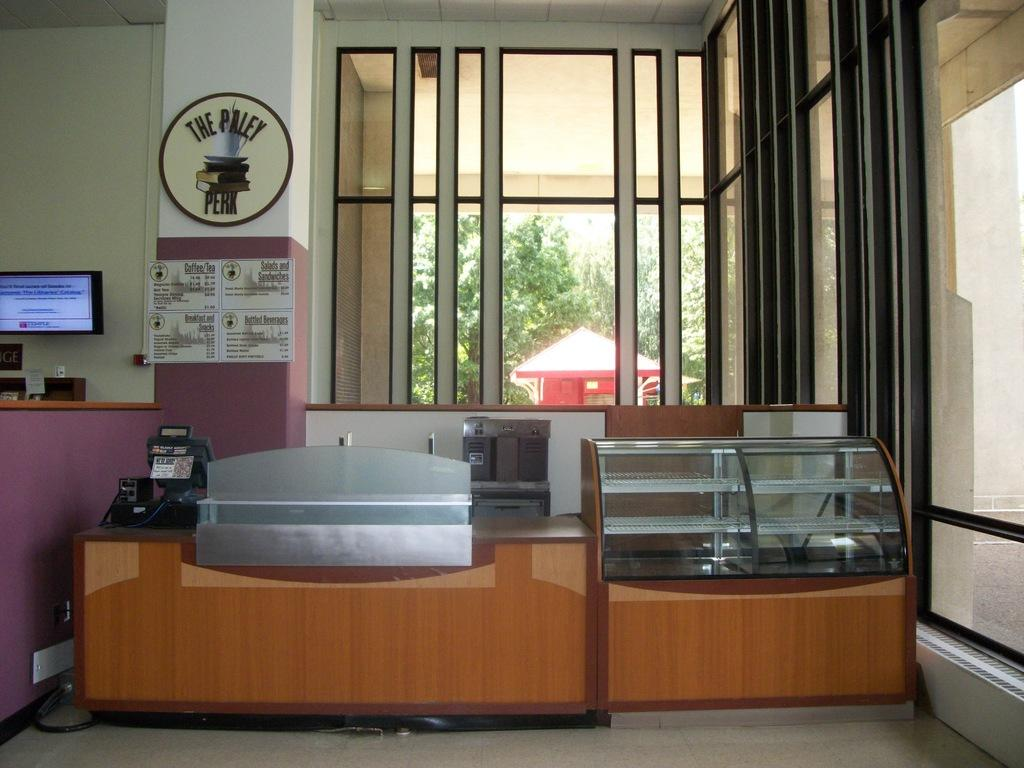What is the main object in the middle of the picture? There is a desk in the middle of the picture. What can be seen in the background of the picture? There is a window and plants visible in the background of the picture. How much wealth is displayed on the desk in the image? There is no indication of wealth or any financial items on the desk in the image. 